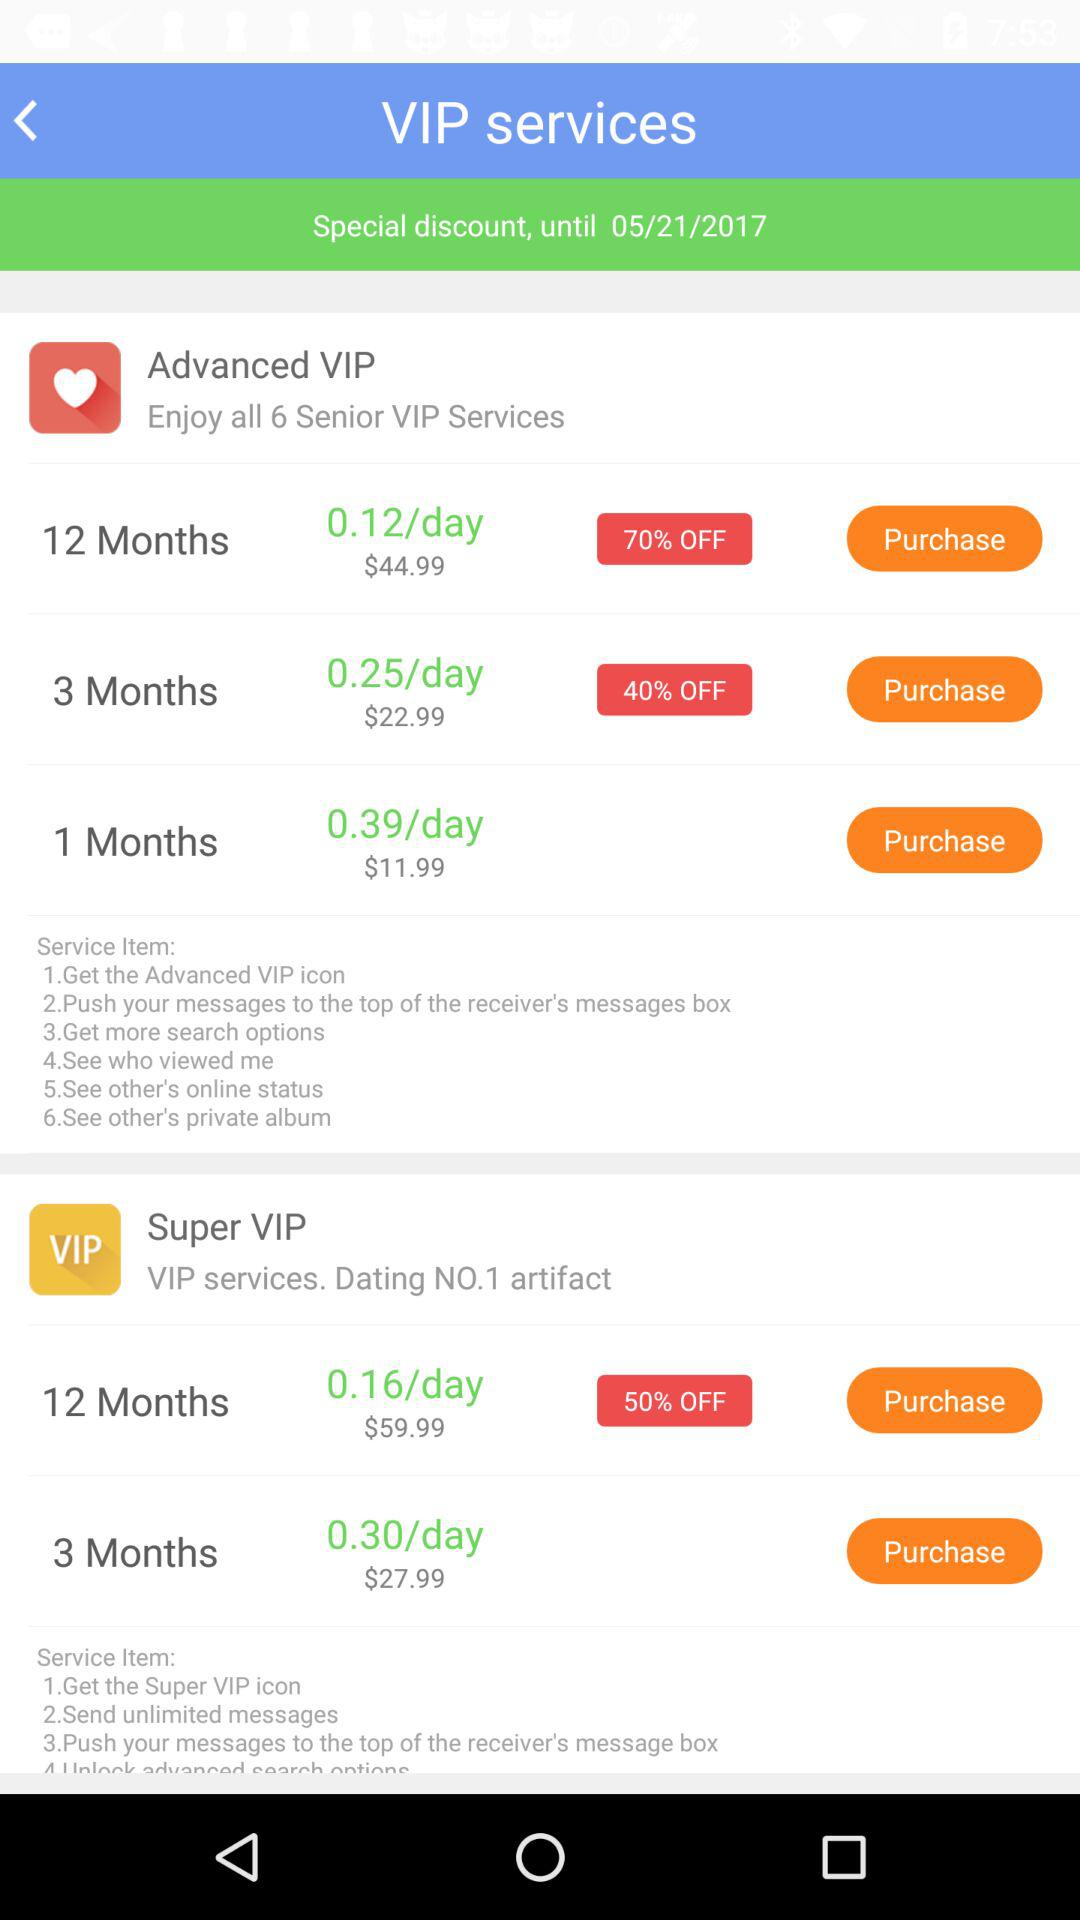What is the price of the Advanced VIP subscription per day for 1 month? The price of the Advanced VIP subscription per day for 1 month is $0.39. 